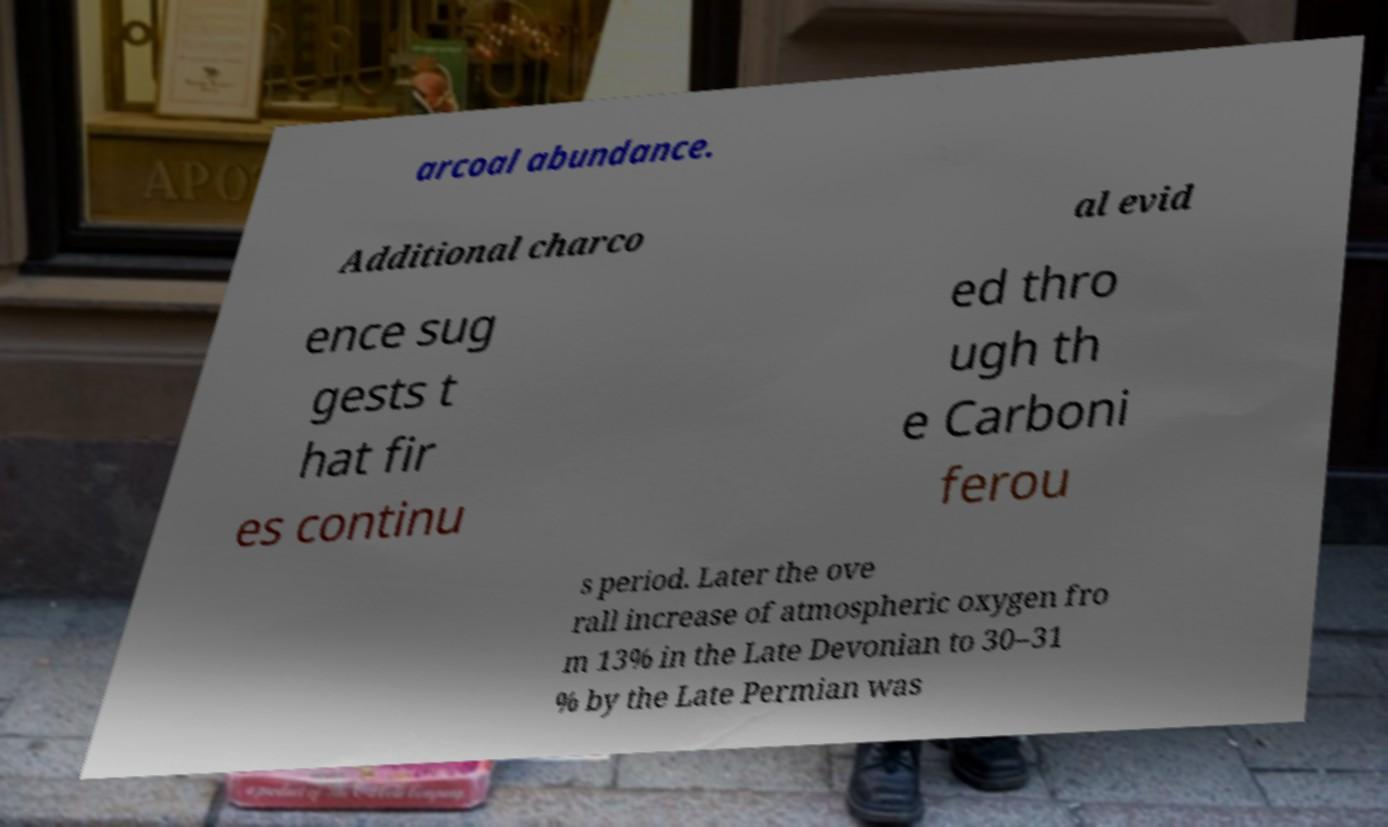Could you assist in decoding the text presented in this image and type it out clearly? arcoal abundance. Additional charco al evid ence sug gests t hat fir es continu ed thro ugh th e Carboni ferou s period. Later the ove rall increase of atmospheric oxygen fro m 13% in the Late Devonian to 30–31 % by the Late Permian was 